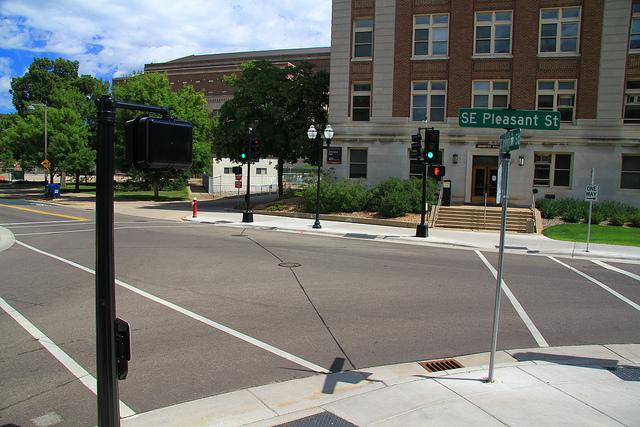Is it a sunny day?
Answer briefly. Yes. Is the street empty?
Quick response, please. Yes. What color is her jacket?
Write a very short answer. No jacket. What is the name of the street?
Be succinct. Se pleasant st. 